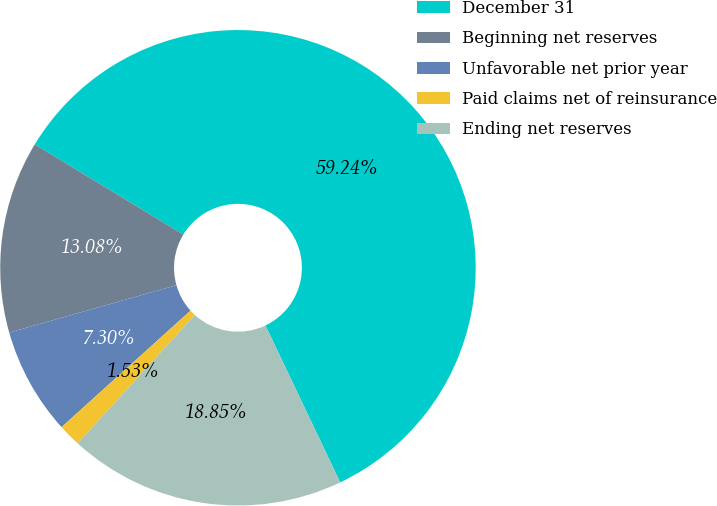Convert chart. <chart><loc_0><loc_0><loc_500><loc_500><pie_chart><fcel>December 31<fcel>Beginning net reserves<fcel>Unfavorable net prior year<fcel>Paid claims net of reinsurance<fcel>Ending net reserves<nl><fcel>59.24%<fcel>13.08%<fcel>7.3%<fcel>1.53%<fcel>18.85%<nl></chart> 